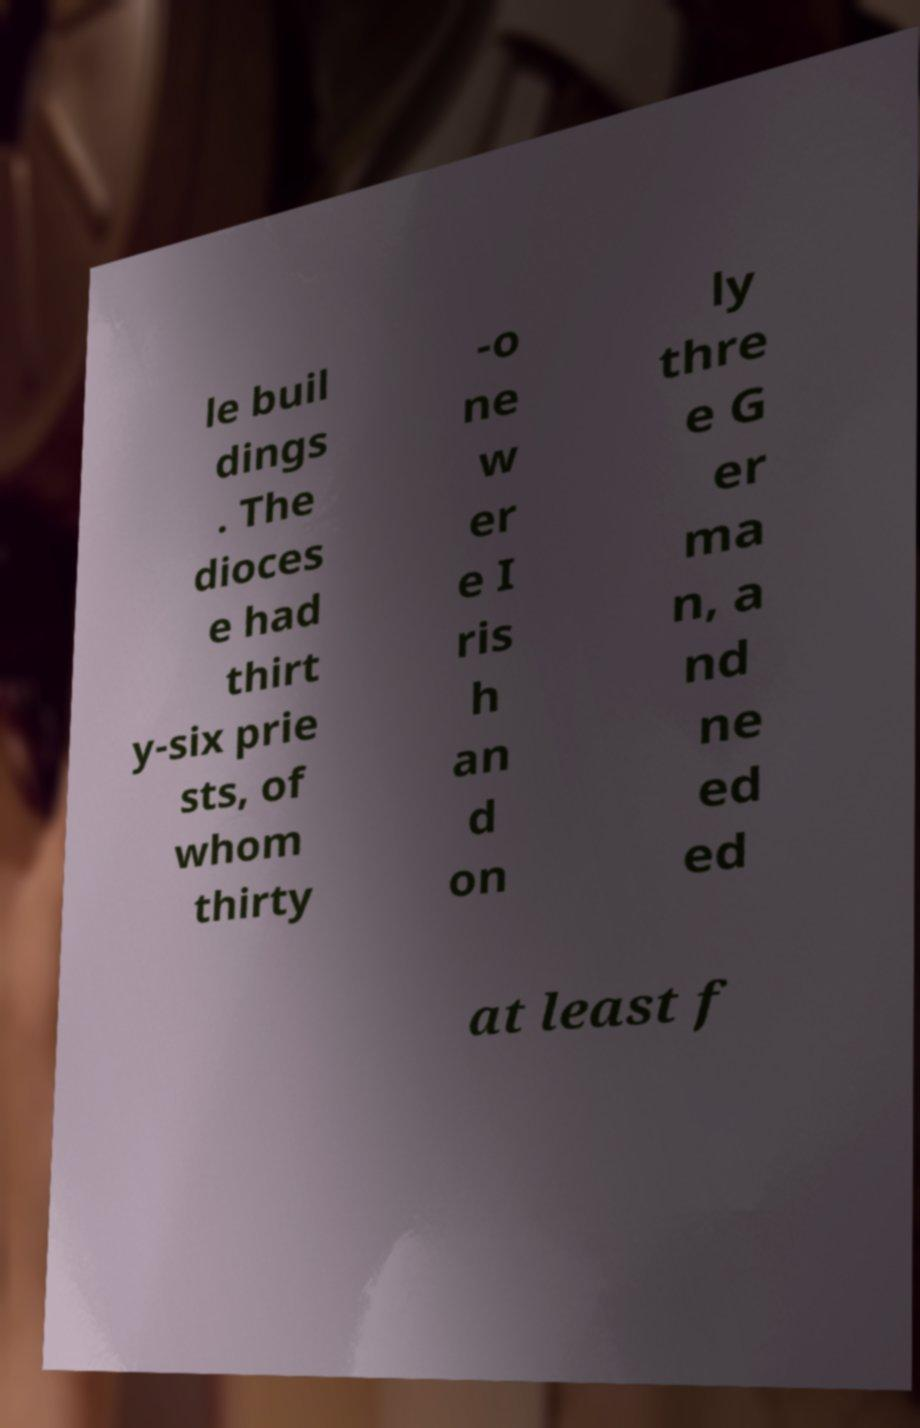Could you extract and type out the text from this image? le buil dings . The dioces e had thirt y-six prie sts, of whom thirty -o ne w er e I ris h an d on ly thre e G er ma n, a nd ne ed ed at least f 